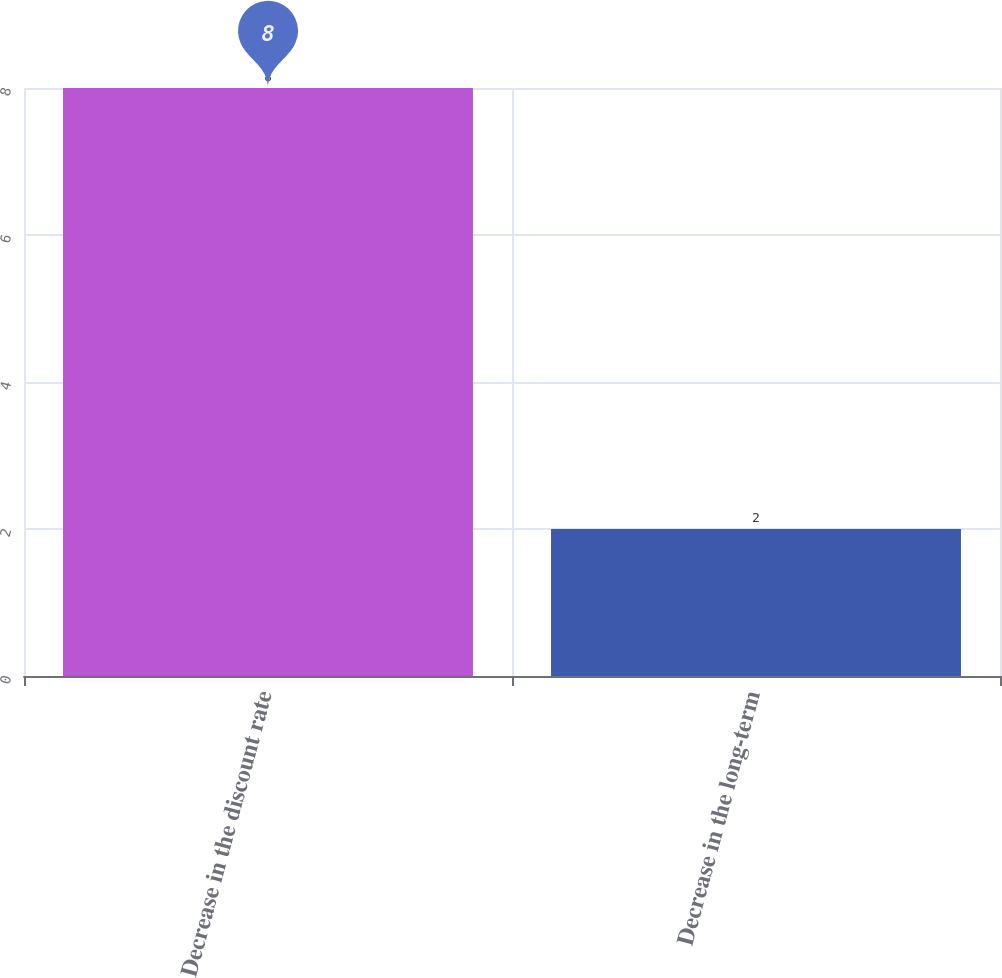Convert chart to OTSL. <chart><loc_0><loc_0><loc_500><loc_500><bar_chart><fcel>Decrease in the discount rate<fcel>Decrease in the long-term<nl><fcel>8<fcel>2<nl></chart> 